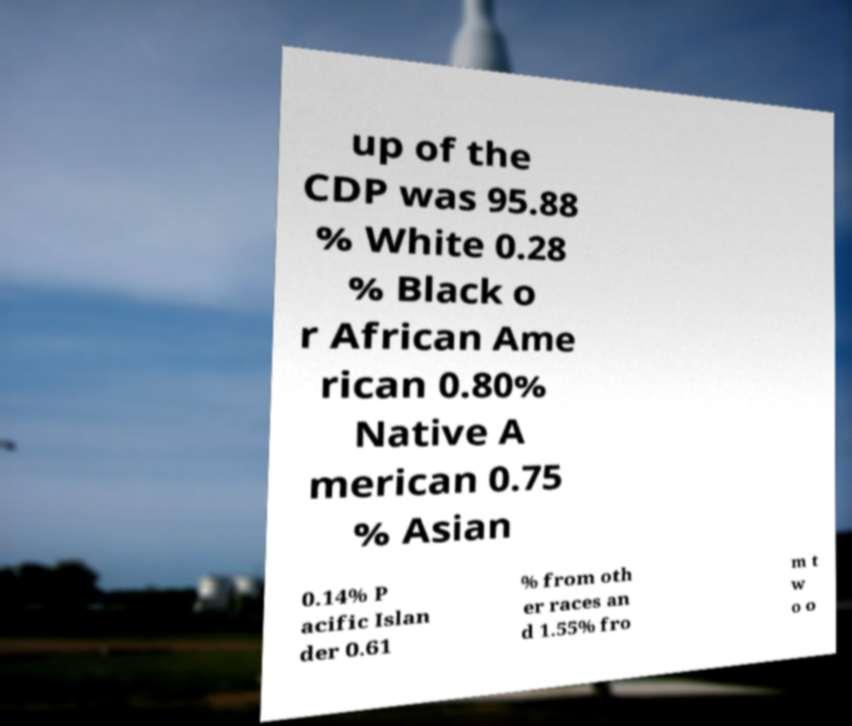I need the written content from this picture converted into text. Can you do that? up of the CDP was 95.88 % White 0.28 % Black o r African Ame rican 0.80% Native A merican 0.75 % Asian 0.14% P acific Islan der 0.61 % from oth er races an d 1.55% fro m t w o o 